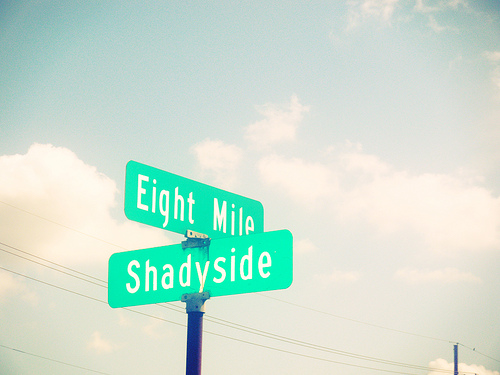How many letters are there in the bottom street sign? The bottom street sign reads 'Shadyside,' which consists of 9 letters. It's interesting to note that 'Shadyside' could refer to the name of a street or perhaps a specific area or neighborhood. Typically, street signs like these are designed with high-contrast colors for better visibility and legibility. 